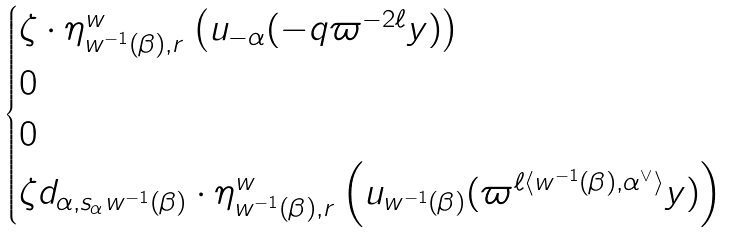Convert formula to latex. <formula><loc_0><loc_0><loc_500><loc_500>\begin{cases} \zeta \cdot \eta ^ { w } _ { w ^ { - 1 } ( \beta ) , r } \left ( u _ { - \alpha } ( - q \varpi ^ { - 2 \ell } y ) \right ) & \\ 0 & \\ 0 & \\ \zeta d _ { \alpha , s _ { \alpha } w ^ { - 1 } ( \beta ) } \cdot \eta _ { w ^ { - 1 } ( \beta ) , r } ^ { w } \left ( u _ { w ^ { - 1 } ( \beta ) } ( \varpi ^ { \ell \langle w ^ { - 1 } ( \beta ) , \alpha ^ { \vee } \rangle } y ) \right ) & \end{cases}</formula> 